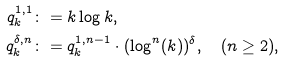Convert formula to latex. <formula><loc_0><loc_0><loc_500><loc_500>q ^ { 1 , 1 } _ { k } & \colon = k \log k , \\ q ^ { \delta , n } _ { k } & \colon = q ^ { 1 , n - 1 } _ { k } \cdot ( \log ^ { n } ( k ) ) ^ { \delta } , \quad ( n \geq 2 ) ,</formula> 